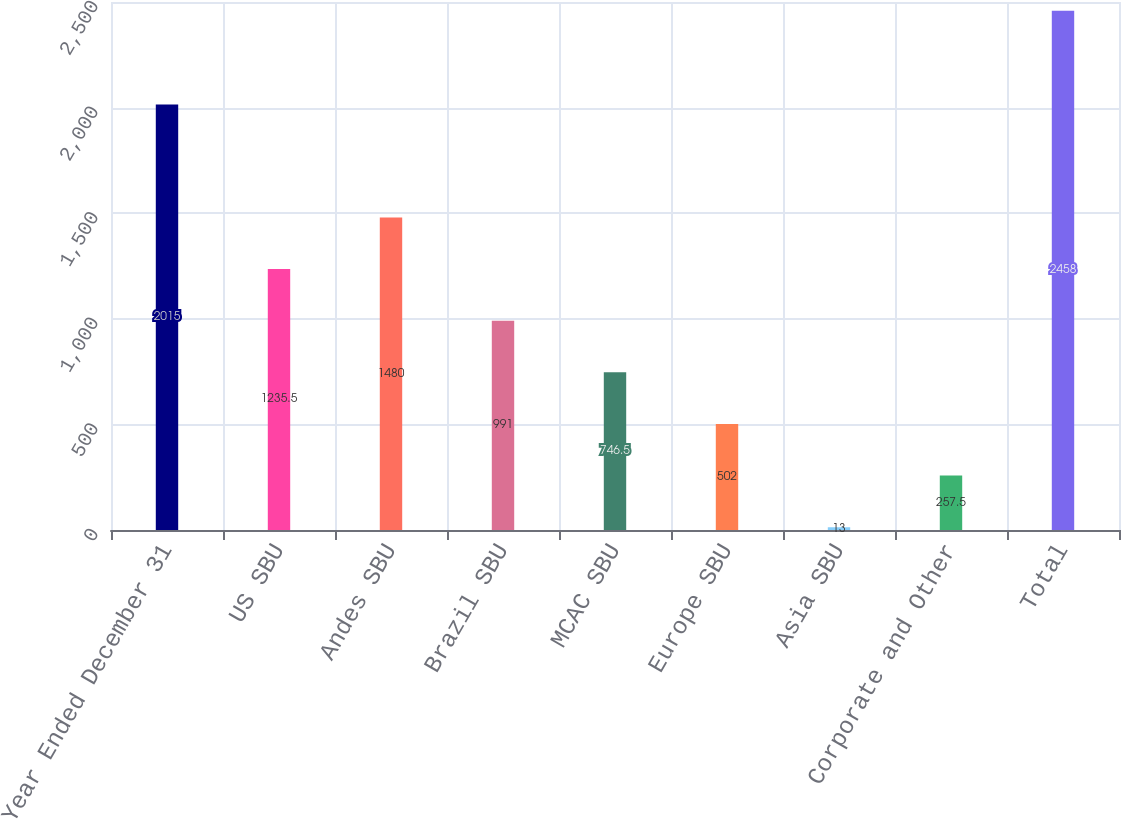Convert chart. <chart><loc_0><loc_0><loc_500><loc_500><bar_chart><fcel>Year Ended December 31<fcel>US SBU<fcel>Andes SBU<fcel>Brazil SBU<fcel>MCAC SBU<fcel>Europe SBU<fcel>Asia SBU<fcel>Corporate and Other<fcel>Total<nl><fcel>2015<fcel>1235.5<fcel>1480<fcel>991<fcel>746.5<fcel>502<fcel>13<fcel>257.5<fcel>2458<nl></chart> 